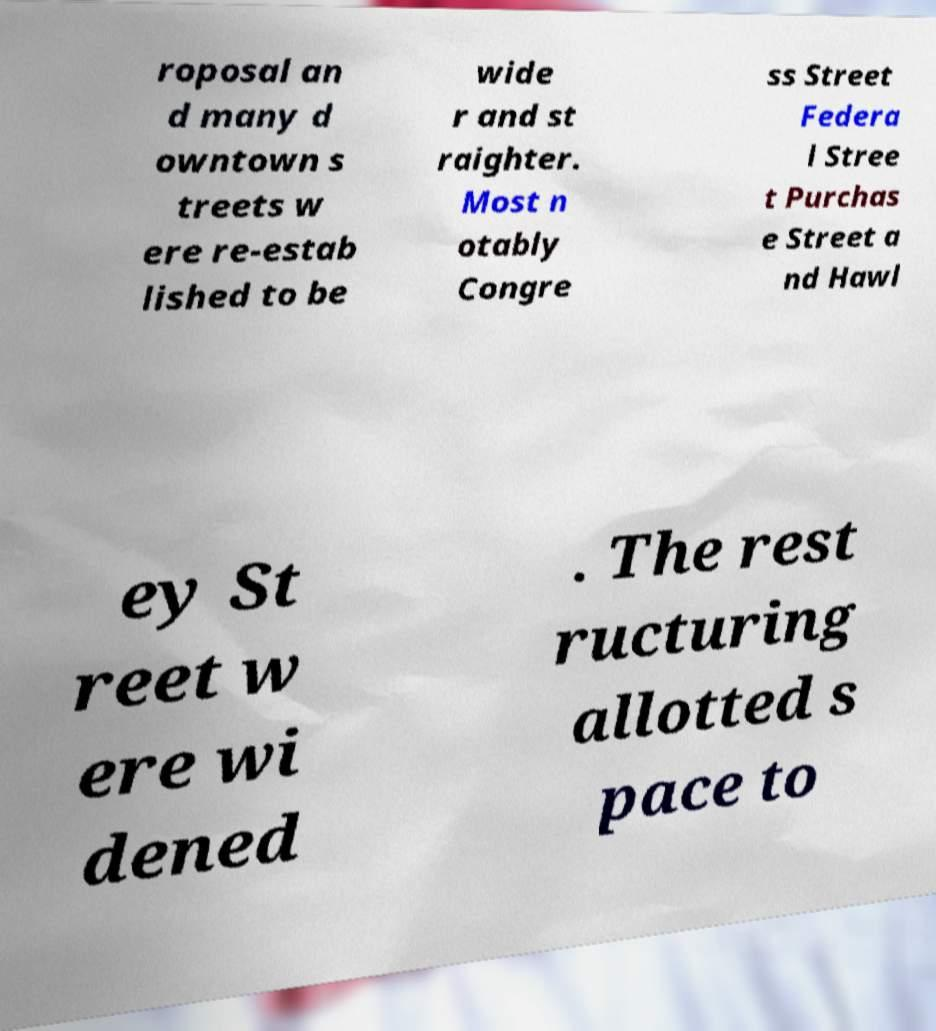Please identify and transcribe the text found in this image. roposal an d many d owntown s treets w ere re-estab lished to be wide r and st raighter. Most n otably Congre ss Street Federa l Stree t Purchas e Street a nd Hawl ey St reet w ere wi dened . The rest ructuring allotted s pace to 